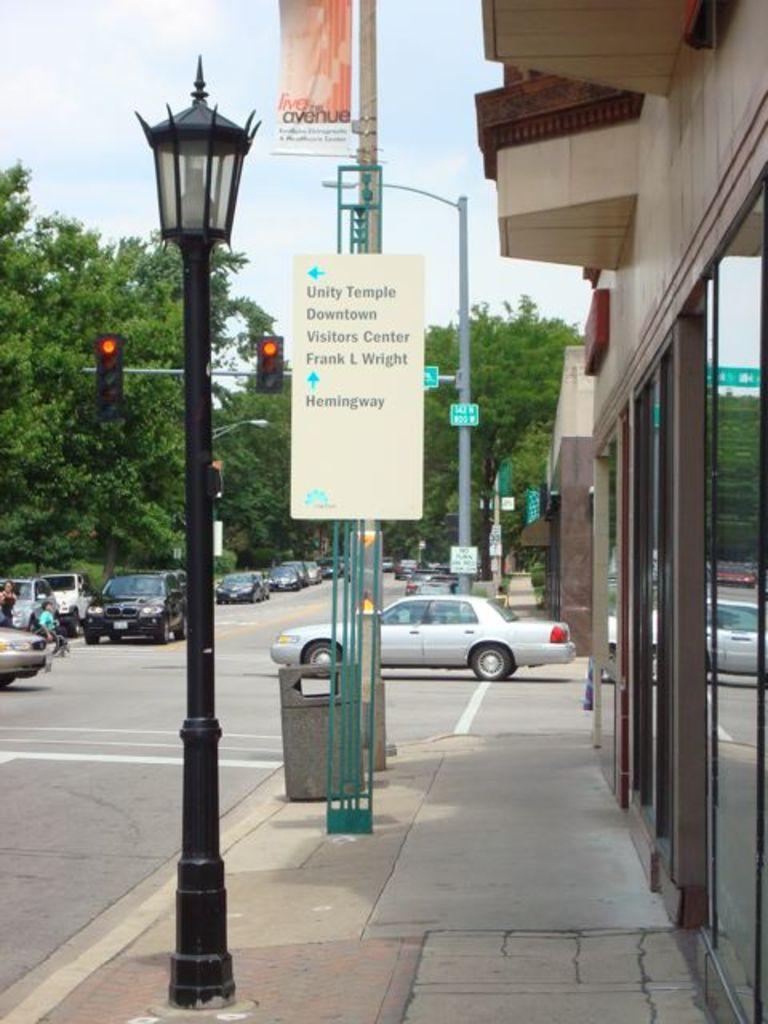In one or two sentences, can you explain what this image depicts? This picture shows buildings and we see trees and few cars on the road and we see couple of them crossing the road and we see a dustbin and few boards to the poles and traffic signal lights and pole lights and a cloudy Sky. 